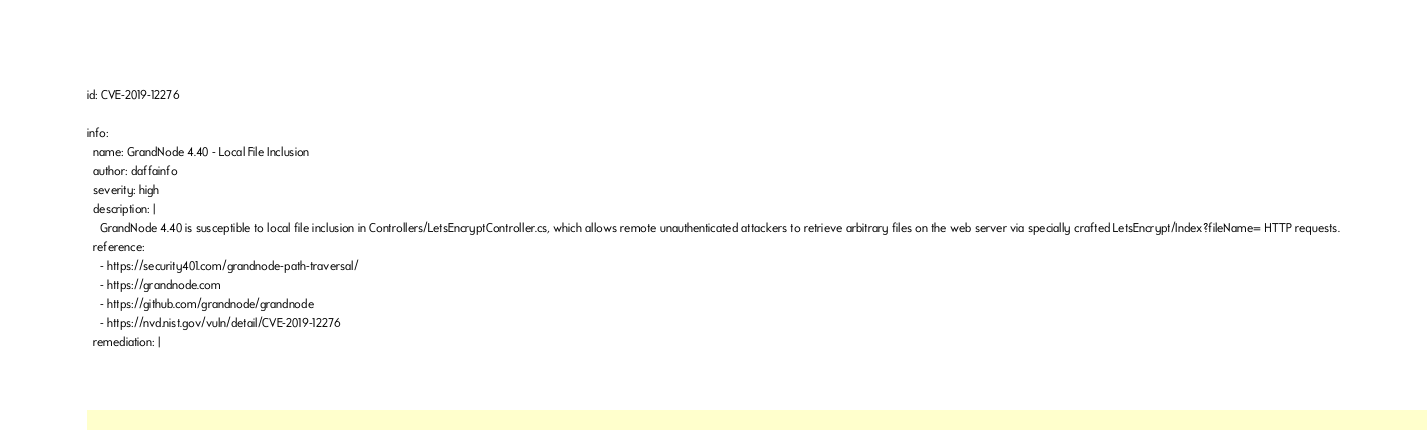<code> <loc_0><loc_0><loc_500><loc_500><_YAML_>id: CVE-2019-12276

info:
  name: GrandNode 4.40 - Local File Inclusion
  author: daffainfo
  severity: high
  description: |
    GrandNode 4.40 is susceptible to local file inclusion in Controllers/LetsEncryptController.cs, which allows remote unauthenticated attackers to retrieve arbitrary files on the web server via specially crafted LetsEncrypt/Index?fileName= HTTP requests.
  reference:
    - https://security401.com/grandnode-path-traversal/
    - https://grandnode.com
    - https://github.com/grandnode/grandnode
    - https://nvd.nist.gov/vuln/detail/CVE-2019-12276
  remediation: |</code> 